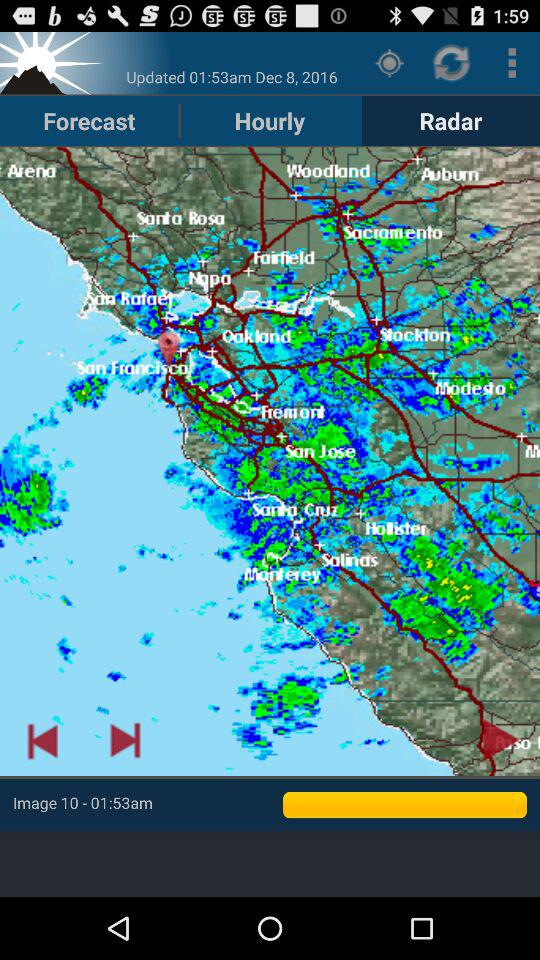What is the image number? The image number is 10. 